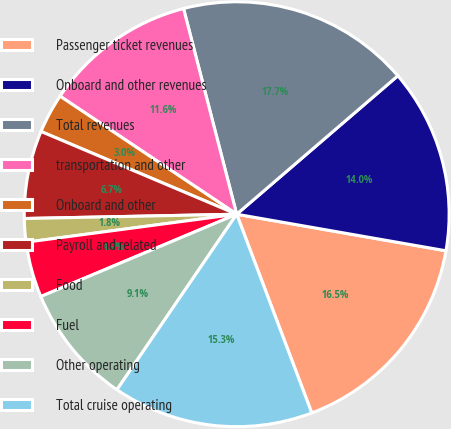Convert chart. <chart><loc_0><loc_0><loc_500><loc_500><pie_chart><fcel>Passenger ticket revenues<fcel>Onboard and other revenues<fcel>Total revenues<fcel>transportation and other<fcel>Onboard and other<fcel>Payroll and related<fcel>Food<fcel>Fuel<fcel>Other operating<fcel>Total cruise operating<nl><fcel>16.5%<fcel>14.05%<fcel>17.73%<fcel>11.6%<fcel>3.01%<fcel>6.69%<fcel>1.78%<fcel>4.23%<fcel>9.14%<fcel>15.28%<nl></chart> 